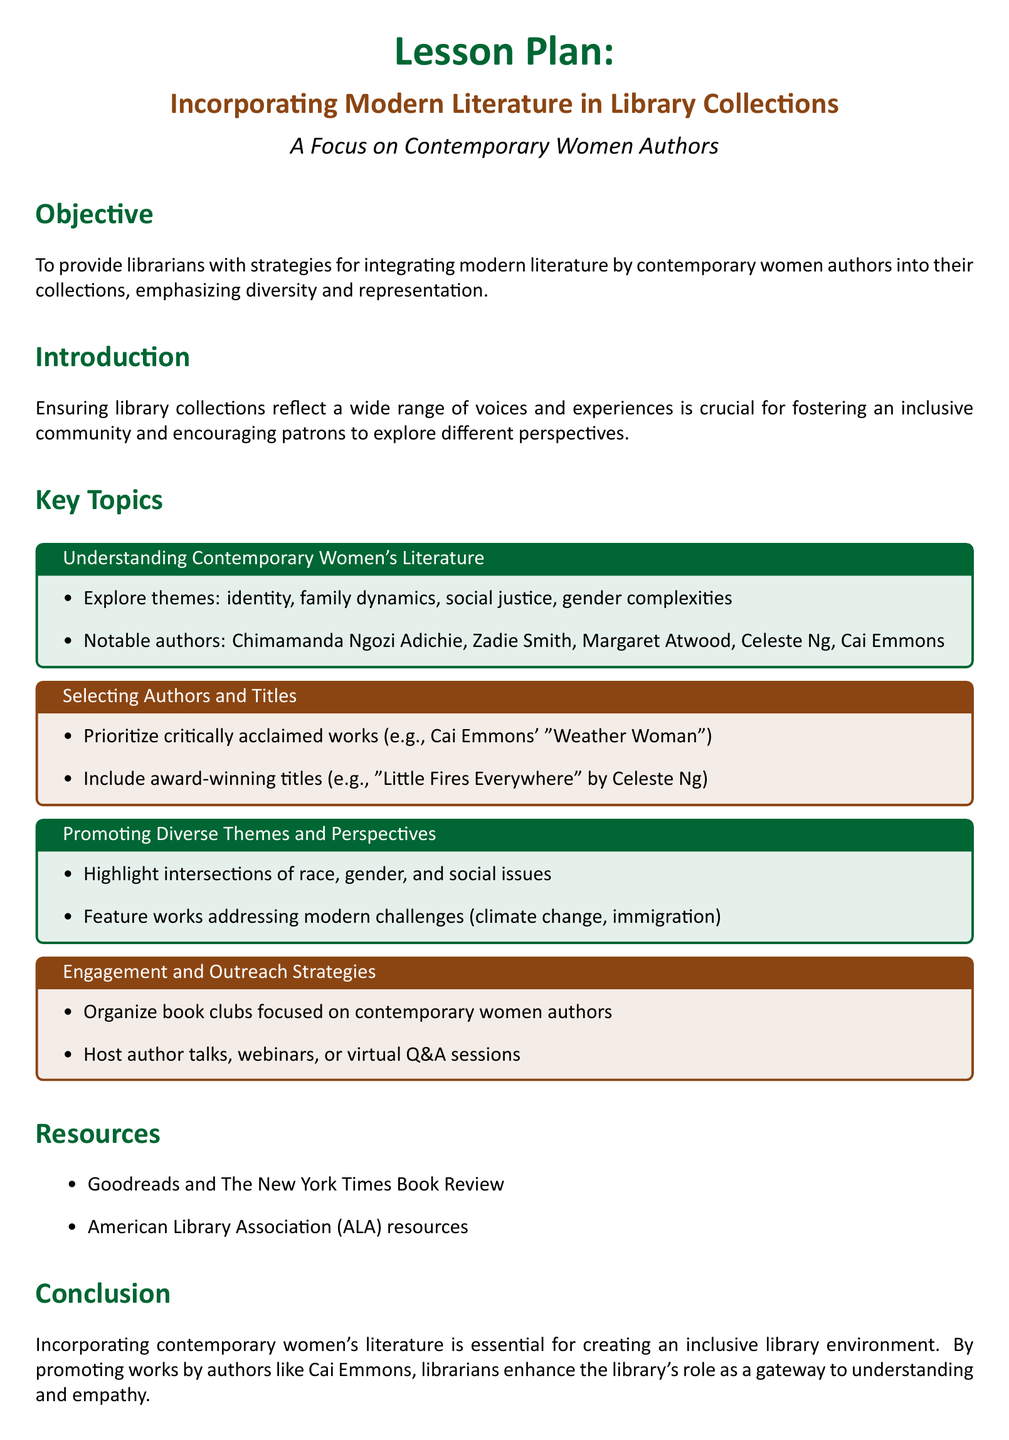What is the primary objective of the lesson plan? The objective is to provide librarians with strategies for integrating modern literature by contemporary women authors into their collections, emphasizing diversity and representation.
Answer: To provide librarians with strategies for integrating modern literature by contemporary women authors into their collections, emphasizing diversity and representation Which author is specifically mentioned as a notable figure in contemporary women's literature? Cai Emmons is listed as a notable author in the document, highlighting her importance in the context of contemporary women's literature.
Answer: Cai Emmons What are two themes explored in contemporary women's literature? The document lists themes such as identity, family dynamics, social justice, and gender complexities, indicating the diverse topics these authors engage with.
Answer: Identity, family dynamics Name one award-winning title suggested in the lesson plan. One suggested award-winning title is "Little Fires Everywhere," which is by Celeste Ng and fits the criteria of critically acclaimed works.
Answer: Little Fires Everywhere What action step involves community engagement? Engaging with the community is highlighted as a crucial step in understanding the interests of library patrons and enhancing collection diversity.
Answer: Engage with community to understand interests How many key topics are discussed in the lesson plan? The document outlines multiple key topics, organized into specific sections, suggesting a structured approach to covering contemporary women's literature.
Answer: Four Which organization is mentioned as a resource in the lesson plan? The American Library Association (ALA) is highlighted as a valuable resource for librarians looking to enhance their collections with contemporary women's literature.
Answer: American Library Association What type of events are suggested for engagement with patrons? The lesson plan recommends organizing book clubs focused on contemporary women authors and hosting author talks, webinars, or Q&A sessions as outreach activities.
Answer: Book clubs, author talks 